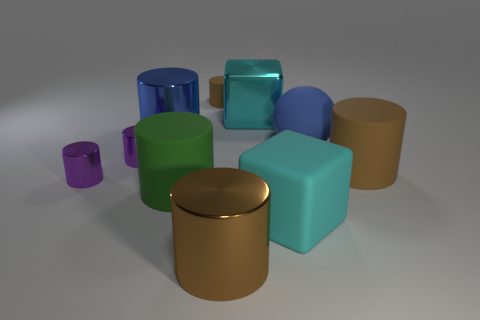Subtract all large brown cylinders. How many cylinders are left? 5 Subtract all cubes. How many objects are left? 8 Subtract all green cylinders. How many cylinders are left? 6 Subtract 1 spheres. How many spheres are left? 0 Subtract 0 gray cylinders. How many objects are left? 10 Subtract all brown spheres. Subtract all gray cylinders. How many spheres are left? 1 Subtract all yellow spheres. How many purple cylinders are left? 2 Subtract all big cyan rubber things. Subtract all red balls. How many objects are left? 9 Add 9 blue cylinders. How many blue cylinders are left? 10 Add 1 purple matte cubes. How many purple matte cubes exist? 1 